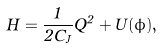<formula> <loc_0><loc_0><loc_500><loc_500>H = \frac { 1 } { 2 C _ { J } } Q ^ { 2 } + U ( \phi ) ,</formula> 